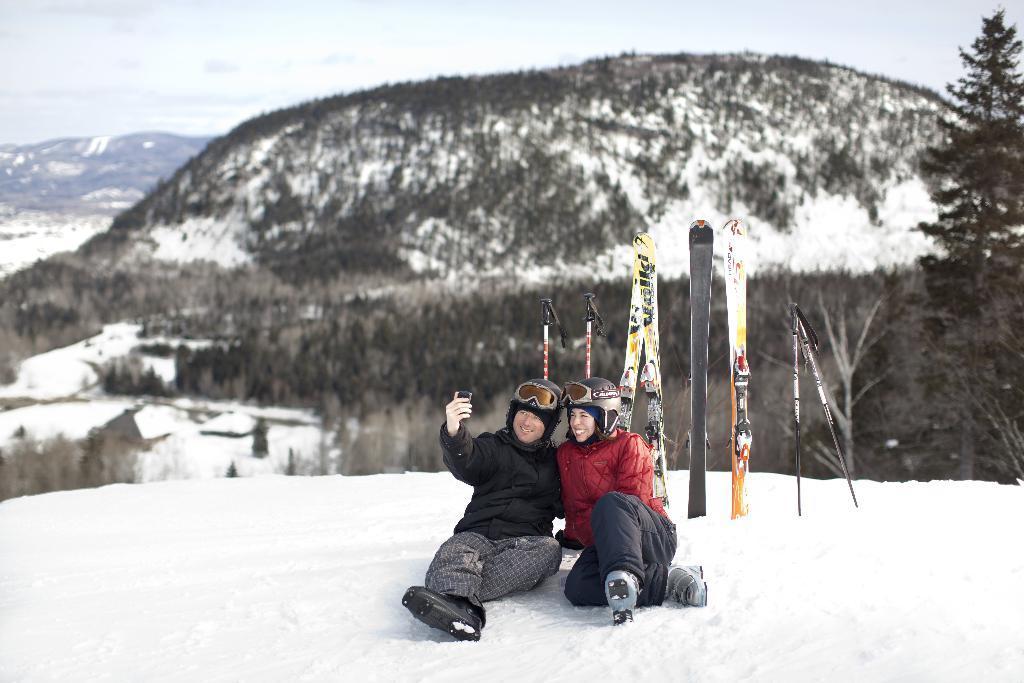How would you summarize this image in a sentence or two? In the center of the image we can see the sticks and two people are sitting on the snow and wearing the jackets, shoes, helmets and a man is holding a mobile. In the background of the image we can see the hills, trees and snow. At the top of the image we can see the sky. 